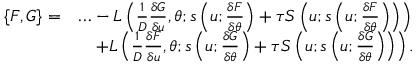<formula> <loc_0><loc_0><loc_500><loc_500>\begin{array} { r l } { \{ F , G \} = } & { \dots - L \left ( \frac { 1 } { D } \frac { \delta G } { \delta u } , \theta ; s \left ( u ; \frac { \delta F } { \delta \theta } \right ) + \tau S \left ( u ; s \left ( u ; \frac { \delta F } { \delta \theta } \right ) \right ) \right ) } \\ & { \quad + L \left ( \frac { 1 } { D } \frac { \delta F } { \delta u } , \theta ; s \left ( u ; \frac { \delta G } { \delta \theta } \right ) + \tau S \left ( u ; s \left ( u ; \frac { \delta G } { \delta \theta } \right ) \right ) \right ) . } \end{array}</formula> 